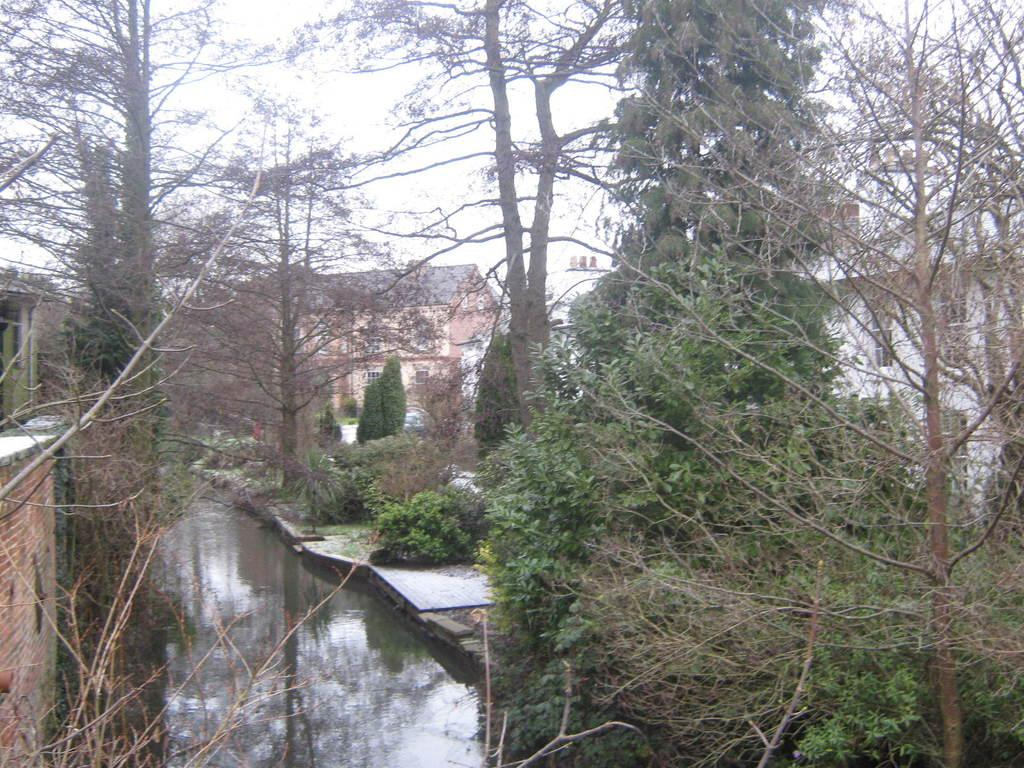What type of natural vegetation is present in the image? There are trees in the image. What type of man-made structures can be seen in the image? There are buildings in the image. What type of living organisms are present in the image besides trees? There are plants in the image. What type of natural element is visible in the image? There is water visible in the image. What type of objects are present in the image? There are objects in the image. What type of architectural feature is present in the image? There are windows in the image. What part of the natural environment is visible in the image? The sky is visible in the image. Can you see any fire or flames in the image? There is no fire or flames present in the image. Is there a bath or bathtub visible in the image? There is no bath or bathtub present in the image. 